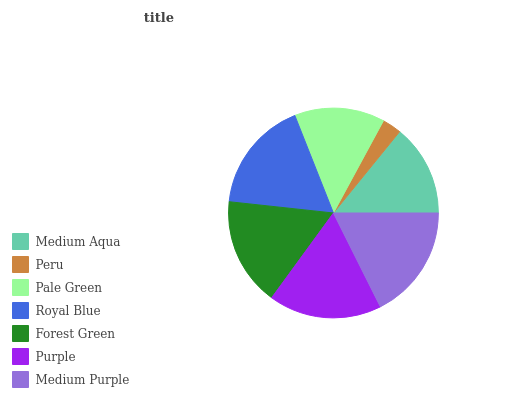Is Peru the minimum?
Answer yes or no. Yes. Is Medium Purple the maximum?
Answer yes or no. Yes. Is Pale Green the minimum?
Answer yes or no. No. Is Pale Green the maximum?
Answer yes or no. No. Is Pale Green greater than Peru?
Answer yes or no. Yes. Is Peru less than Pale Green?
Answer yes or no. Yes. Is Peru greater than Pale Green?
Answer yes or no. No. Is Pale Green less than Peru?
Answer yes or no. No. Is Forest Green the high median?
Answer yes or no. Yes. Is Forest Green the low median?
Answer yes or no. Yes. Is Medium Purple the high median?
Answer yes or no. No. Is Purple the low median?
Answer yes or no. No. 